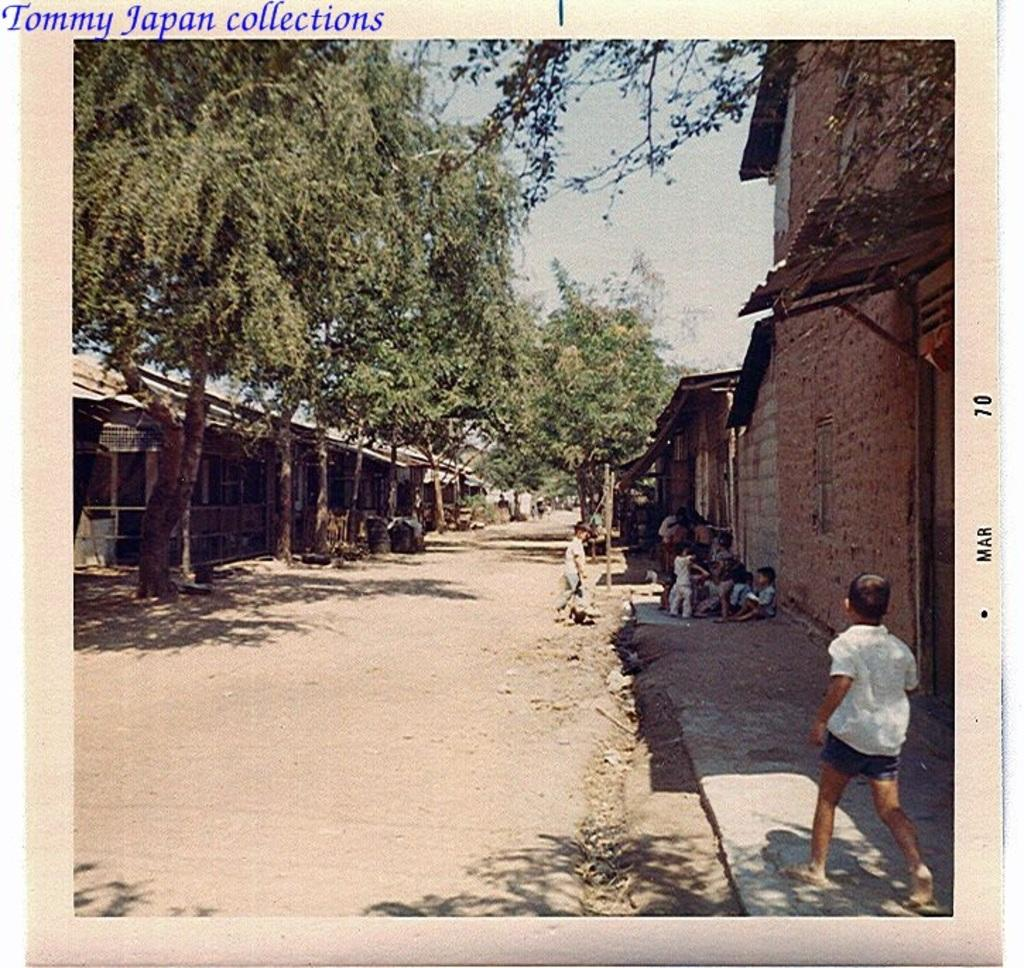How many people are in the image? There is a group of people in the image, but the exact number cannot be determined from the provided facts. What type of structures can be seen in the image? There are houses in the image. What other natural elements are present in the image? There are trees in the image. What is the primary mode of transportation in the image? There is a road in the image, which suggests that vehicles might be used for transportation. What is visible in the background of the image? The sky is visible in the background of the image. What type of juice is being squeezed from the sticks in the image? There are no sticks or juice present in the image. What selection of items can be seen on the table in the image? There is no table or selection of items mentioned in the provided facts. 